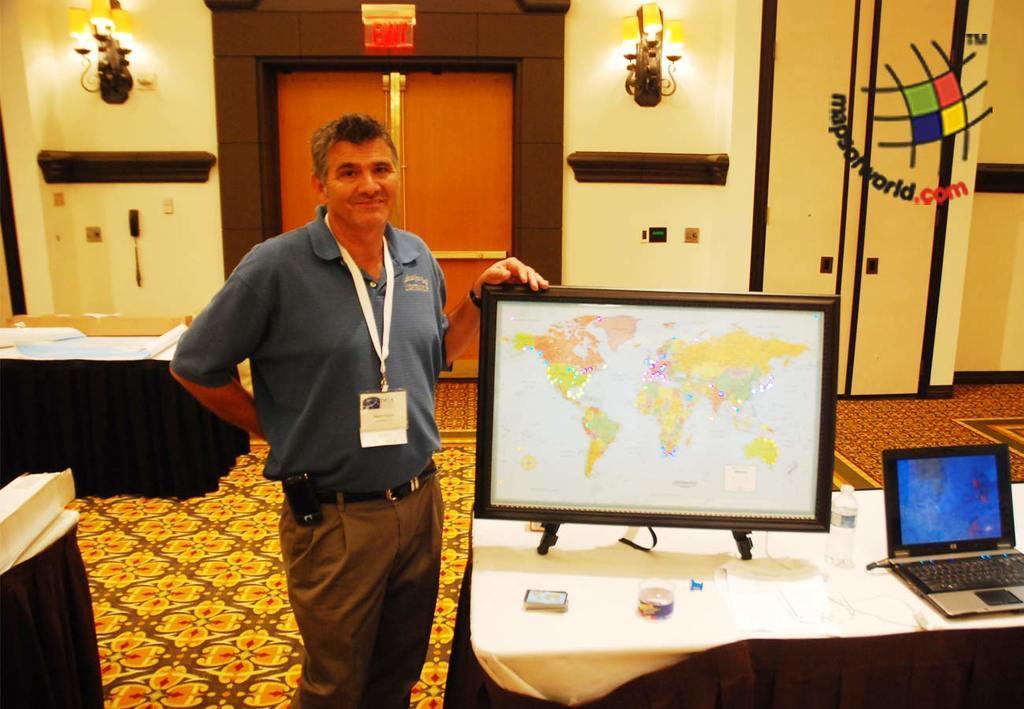In one or two sentences, can you explain what this image depicts? In the center we can see man standing. And we can see the monitor on the table and some more objects. Coming to the background we can see wall,door and some more objects around him. 